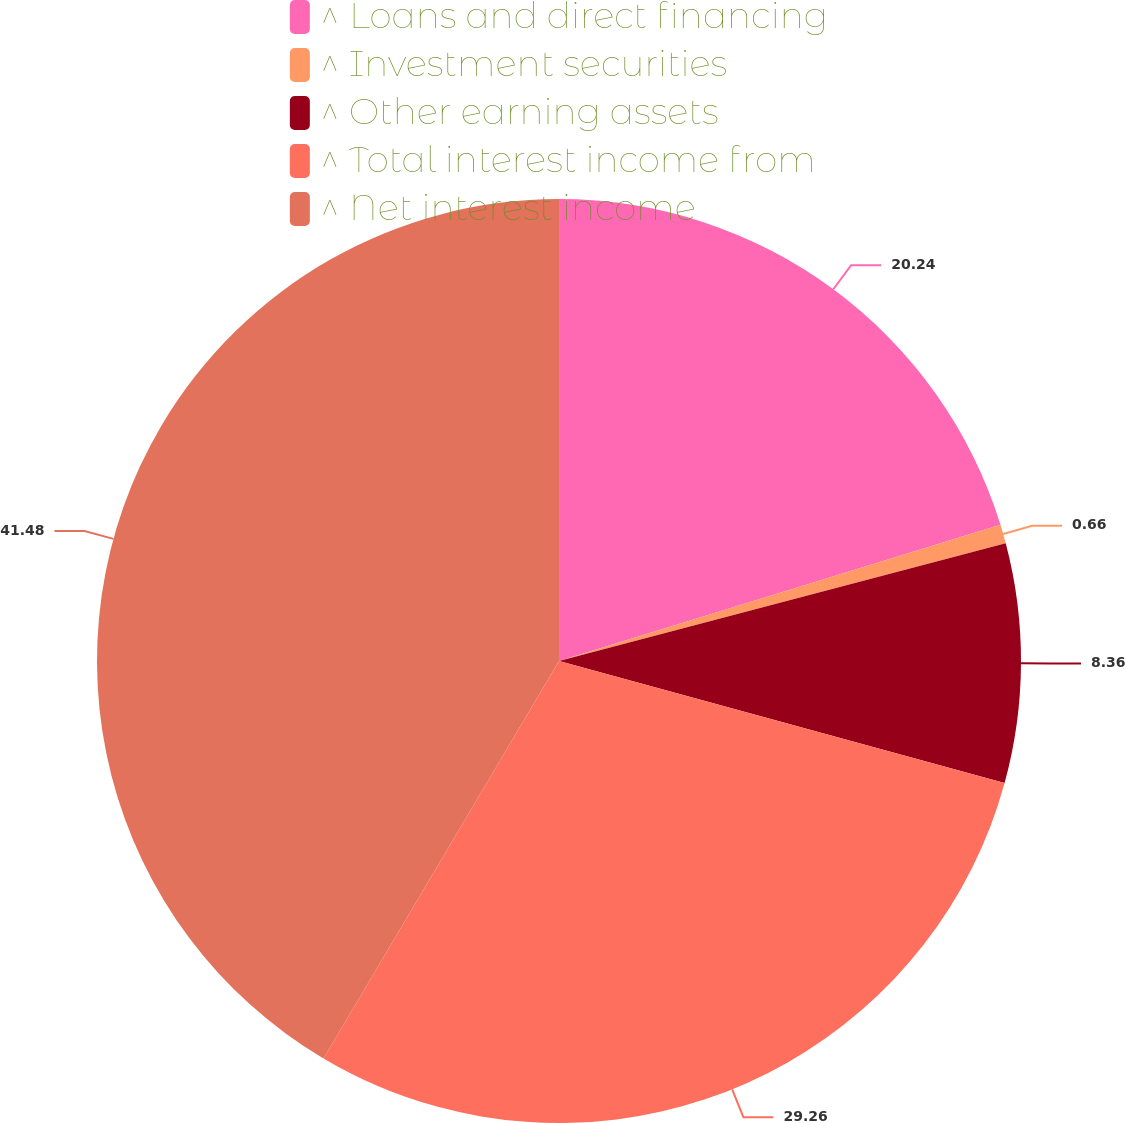<chart> <loc_0><loc_0><loc_500><loc_500><pie_chart><fcel>^ Loans and direct financing<fcel>^ Investment securities<fcel>^ Other earning assets<fcel>^ Total interest income from<fcel>^ Net interest income<nl><fcel>20.24%<fcel>0.66%<fcel>8.36%<fcel>29.26%<fcel>41.49%<nl></chart> 